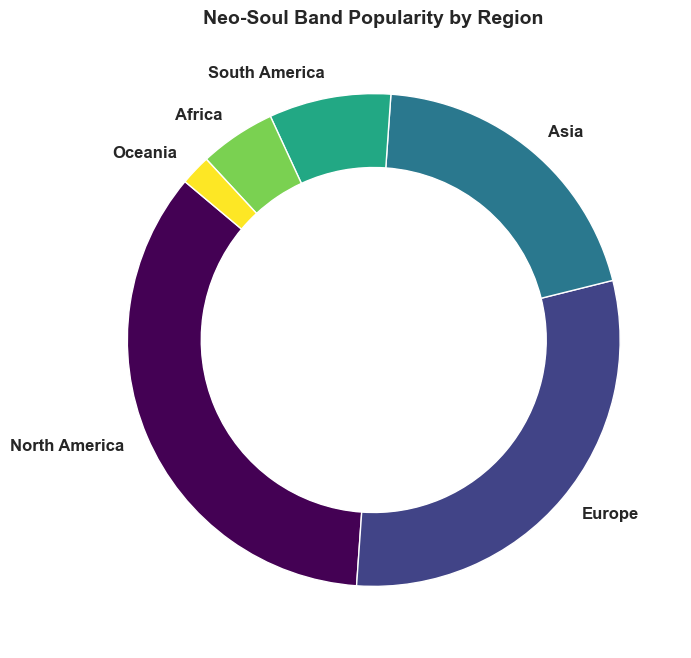What percentage of neo-soul band popularity is in North America and Europe combined? To find the combined percentage of North America and Europe, add their individual percentages: 35% (North America) + 30% (Europe) = 65%.
Answer: 65% Which region has the smallest fanbase for neo-soul bands? The region with the smallest fanbase can be identified by finding the smallest percentage in the data. Oceania has the smallest percentage at 2%.
Answer: Oceania How many regions have a fanbase percentage below 10%? To determine the number of regions with fanbase percentages below 10%, count the regions that fit this criterion: South America (8%), Africa (5%), and Oceania (2%). This totals to 3 regions.
Answer: 3 Is the percentage of neo-soul popularity in Asia greater than in South America and Africa combined? Compare the percentage of Asia (20%) to the combined percentage of South America (8%) and Africa (5%). Adding the percentages of South America and Africa gives 13%, which is less than Asia's 20%.
Answer: Yes What is the difference in the percentage of neo-soul popularity between the regions with the largest and smallest fanbases? Subtract the smallest percentage (Oceania, 2%) from the largest percentage (North America, 35%): 35% - 2% = 33%.
Answer: 33% Which regions have more than 25% of the neo-soul fanbase? Identify regions with percentages greater than 25%: North America (35%) and Europe (30%).
Answer: North America and Europe Is the combined percentage of fanbases in South America and Oceania greater than the fanbase in Africa? Add the percentages of South America (8%) and Oceania (2%): 8% + 2% = 10%. Compare this with Africa's percentage (5%). Since 10% is greater than 5%, the combined percentage is greater.
Answer: Yes Which region has a fanbase closest to 20%? Identify the region whose fanbase percentage is closest to 20%. Asia has exactly 20%.
Answer: Asia What is the average percentage of neo-soul band popularity across all regions? Sum all the percentages and divide by the number of regions: (35% + 30% + 20% + 8% + 5% + 2%) / 6 = 100% / 6 ≈ 16.67%.
Answer: 16.67% How does Europe's neo-soul band popularity compare with the combined fanbase of Africa and Oceania? Compare Europe's percentage (30%) with the combined percentage of Africa (5%) and Oceania (2%): 5% + 2% = 7%. Since 30% is greater than 7%, Europe has a larger fanbase.
Answer: Greater 